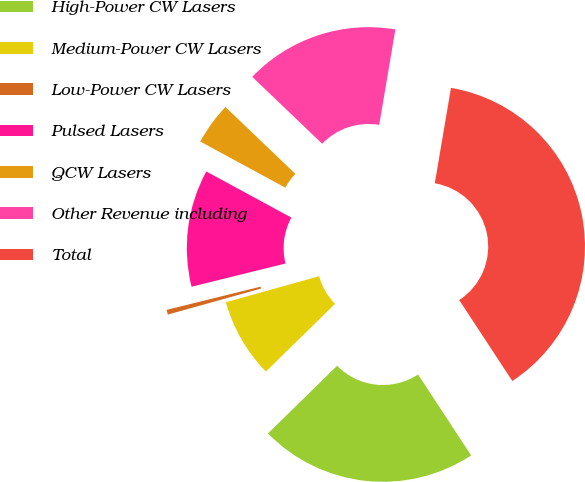<chart> <loc_0><loc_0><loc_500><loc_500><pie_chart><fcel>High-Power CW Lasers<fcel>Medium-Power CW Lasers<fcel>Low-Power CW Lasers<fcel>Pulsed Lasers<fcel>QCW Lasers<fcel>Other Revenue including<fcel>Total<nl><fcel>21.9%<fcel>8.0%<fcel>0.48%<fcel>11.76%<fcel>4.24%<fcel>15.52%<fcel>38.08%<nl></chart> 